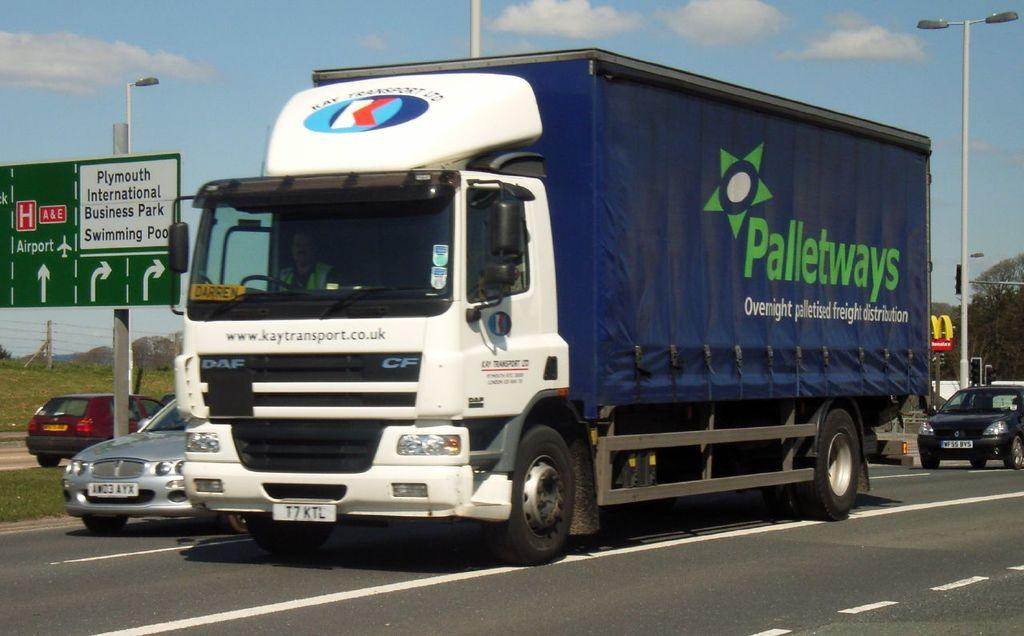What can be seen on the road in the image? There are vehicles on the road in the image. What structures are present alongside the road? There are light poles in the image. What type of vegetation is visible in the background of the image? There are trees in the background of the image. What type of information might be conveyed by the sign board in the image? The sign board on a pole in the image might convey information about directions, warnings, or advertisements. What is visible in the sky in the background of the image? The sky with clouds is visible in the background of the image. How many people are coughing in the image? There are no people present in the image, so it is not possible to determine how many might be coughing. What is the mass of the light poles in the image? The mass of the light poles cannot be determined from the image alone, as it does not provide information about their size or material. 